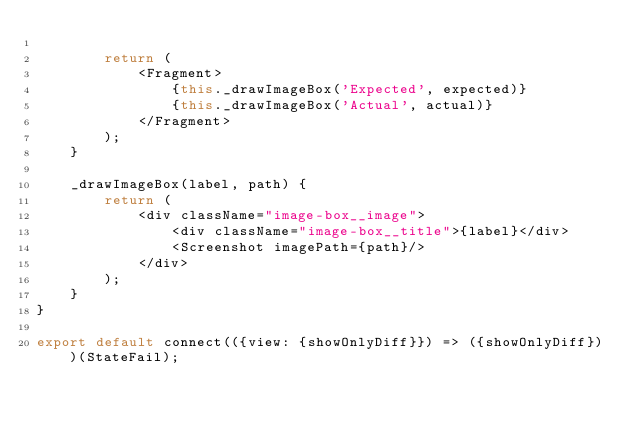<code> <loc_0><loc_0><loc_500><loc_500><_JavaScript_>
        return (
            <Fragment>
                {this._drawImageBox('Expected', expected)}
                {this._drawImageBox('Actual', actual)}
            </Fragment>
        );
    }

    _drawImageBox(label, path) {
        return (
            <div className="image-box__image">
                <div className="image-box__title">{label}</div>
                <Screenshot imagePath={path}/>
            </div>
        );
    }
}

export default connect(({view: {showOnlyDiff}}) => ({showOnlyDiff}))(StateFail);
</code> 